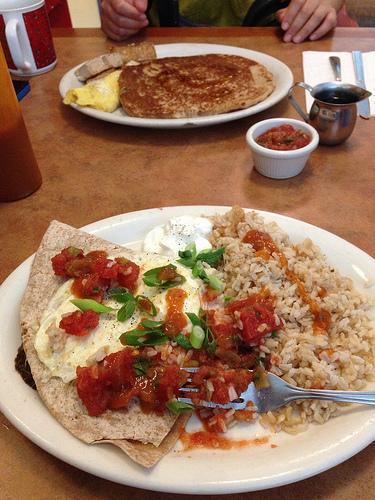How many forks on the table?
Give a very brief answer. 1. How many plates on the table?
Give a very brief answer. 2. How many mugs are seen?
Give a very brief answer. 1. How many napkins can be seen?
Give a very brief answer. 1. 